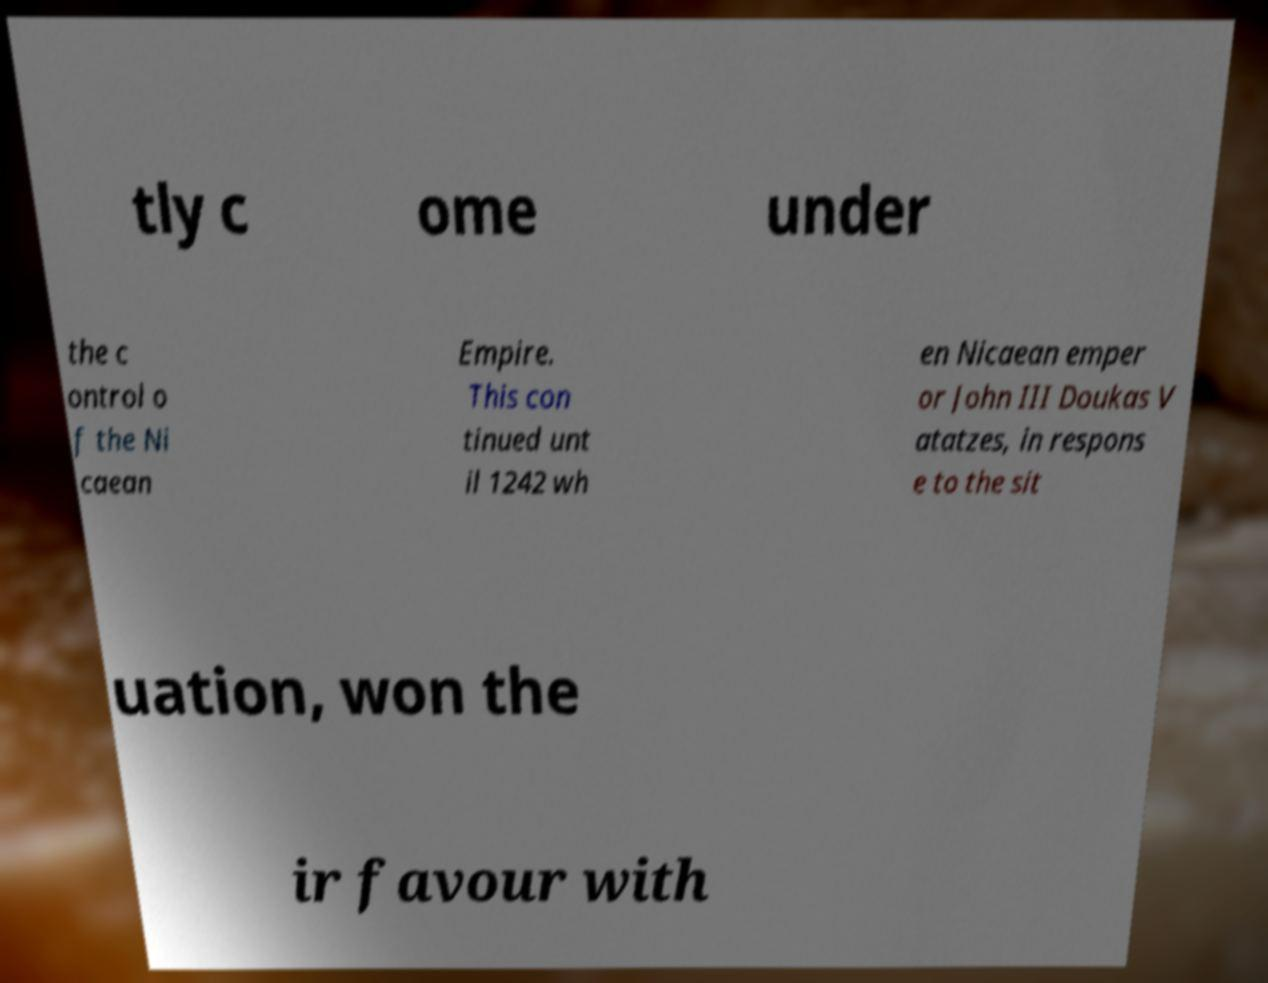There's text embedded in this image that I need extracted. Can you transcribe it verbatim? tly c ome under the c ontrol o f the Ni caean Empire. This con tinued unt il 1242 wh en Nicaean emper or John III Doukas V atatzes, in respons e to the sit uation, won the ir favour with 